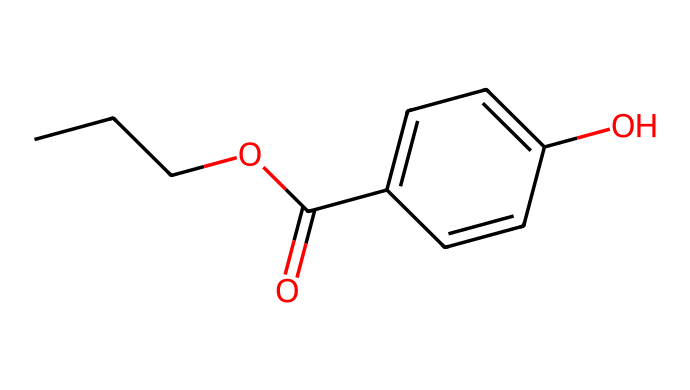What is the chemical name of the compound represented by the SMILES? The SMILES notation corresponds to a chemical structure that can be analyzed. The sequence begins with three carbon atoms (CC), followed by an ether group (OC), and concludes with a para-substituted phenolic structure. Combining these elements gives the full name, propylparaben.
Answer: propylparaben How many carbon atoms are in the compound? By analyzing the SMILES representation, we can count the carbon (C) symbols. There are three carbon atoms at the beginning (CC), plus another six from the aromatic ring (C1=CC=C(C=C1)). This totals to nine carbon atoms in the molecule.
Answer: nine What functional groups are present in propylparaben? Observing the structure in the SMILES reveals multiple functional groups: an ester group (indicated by O=C), a phenol group (OH), and an alkyl chain (C(C)C). These are characteristic of the chemical’s identity.
Answer: ester, phenol What is the degree of unsaturation in propylparaben? The degree of unsaturation can be calculated by counting the rings and double bonds. In propylparaben, there is one aromatic ring (which counts as one degree of unsaturation) and two double bonds in the ring that collectively add to the unsaturation count. Therefore, the total degree of unsaturation is three.
Answer: three Is propylparaben hydrophilic or hydrophobic? Evaluating the structure for polar functional groups, we see a hydroxyl group (OH) which contributes to hydrophilicity. However, the long carbon chain tends toward hydrophobicity. The dominating feature overall in propylparaben points to it being mildly hydrophobic because of the alkyl portion.
Answer: hydrophobic What type of chemical is propylparaben classified as? Propylparaben is indicated by its structure as it has a phenolic core and an ester linking a propyl chain. Based on its characteristics, it is classified as a preservative used in cosmetics, specifically as a paraben.
Answer: preservative 